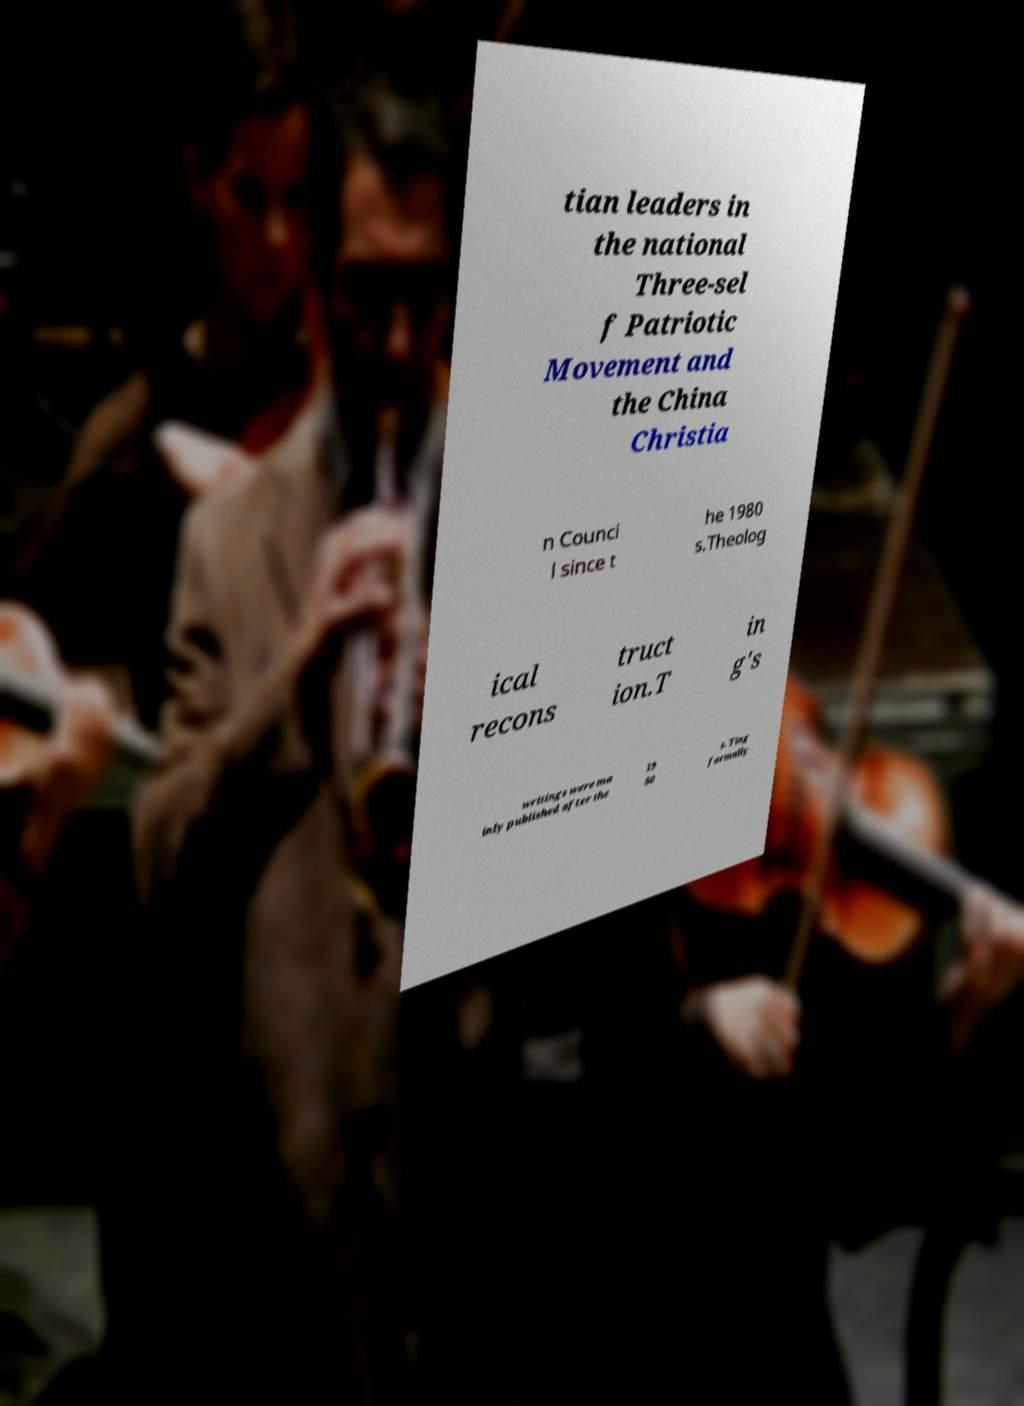There's text embedded in this image that I need extracted. Can you transcribe it verbatim? tian leaders in the national Three-sel f Patriotic Movement and the China Christia n Counci l since t he 1980 s.Theolog ical recons truct ion.T in g's writings were ma inly published after the 19 80 s. Ting formally 